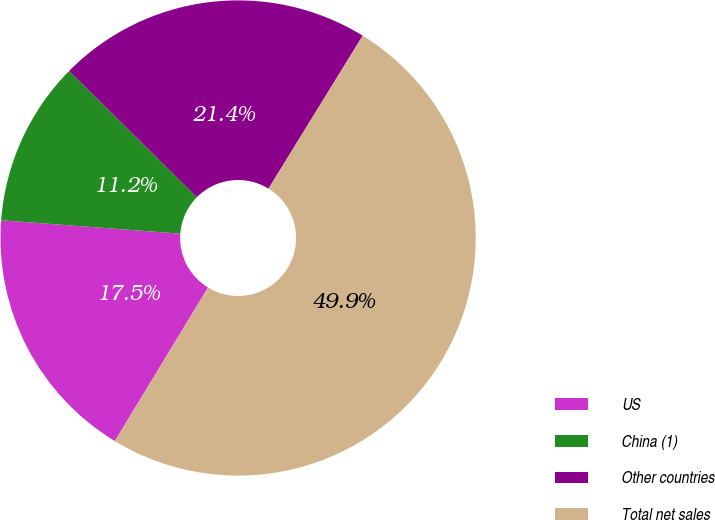<chart> <loc_0><loc_0><loc_500><loc_500><pie_chart><fcel>US<fcel>China (1)<fcel>Other countries<fcel>Total net sales<nl><fcel>17.51%<fcel>11.22%<fcel>21.38%<fcel>49.9%<nl></chart> 